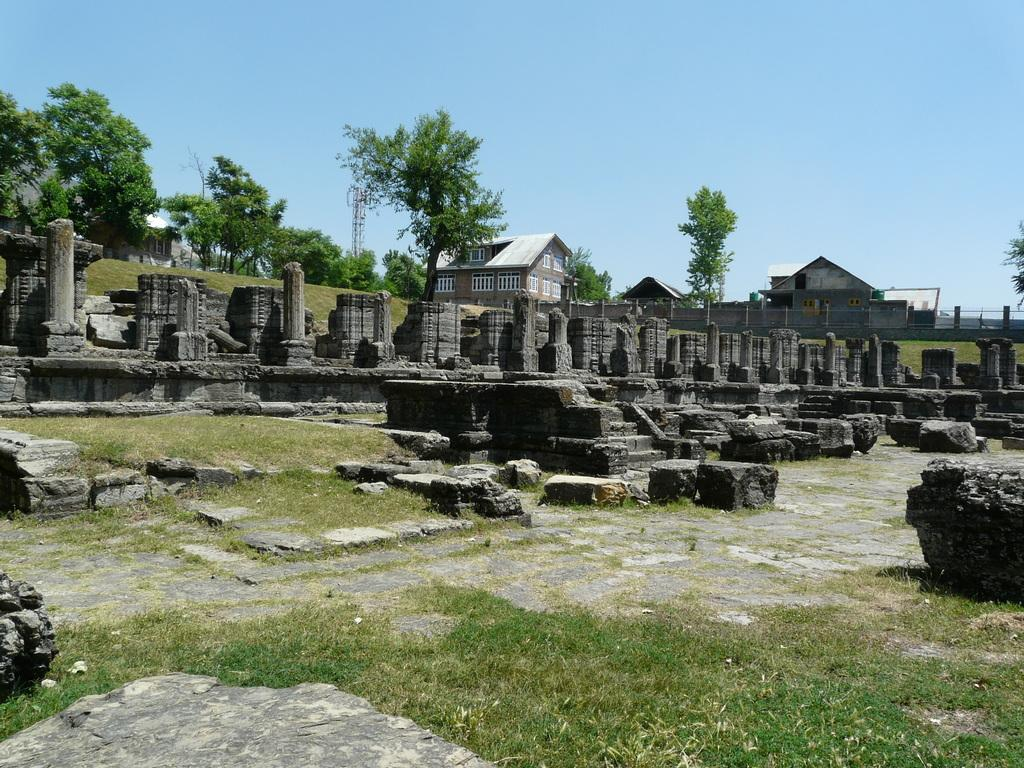What type of vegetation can be seen in the image? There is grass in the image. What other objects can be seen in the image? There are stones, pillars, monuments, trees, houses, towers, windows, and a fence in the image. What is visible in the background of the image? The sky is visible in the image. Can you describe the time of day when the image was likely taken? The image was likely taken during the day, as the sky is visible and there is no indication of darkness. What type of ring can be seen on the monument in the image? There is no ring present on any of the monuments in the image. What season is it in the image, considering the presence of trees and grass? The image does not provide enough information to determine the season, as trees and grass can be present in various seasons. 